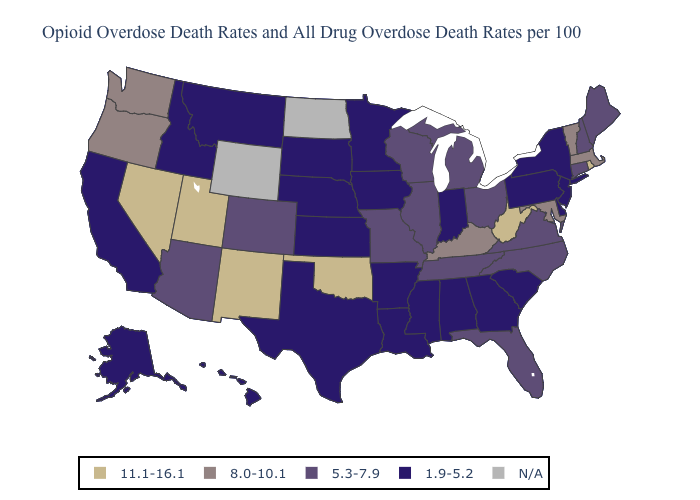Name the states that have a value in the range N/A?
Keep it brief. North Dakota, Wyoming. Which states hav the highest value in the MidWest?
Keep it brief. Illinois, Michigan, Missouri, Ohio, Wisconsin. Name the states that have a value in the range 5.3-7.9?
Answer briefly. Arizona, Colorado, Connecticut, Florida, Illinois, Maine, Michigan, Missouri, New Hampshire, North Carolina, Ohio, Tennessee, Virginia, Wisconsin. What is the lowest value in the South?
Concise answer only. 1.9-5.2. Which states have the lowest value in the West?
Write a very short answer. Alaska, California, Hawaii, Idaho, Montana. Name the states that have a value in the range 11.1-16.1?
Short answer required. Nevada, New Mexico, Oklahoma, Rhode Island, Utah, West Virginia. Name the states that have a value in the range 11.1-16.1?
Quick response, please. Nevada, New Mexico, Oklahoma, Rhode Island, Utah, West Virginia. Does the map have missing data?
Give a very brief answer. Yes. Which states have the lowest value in the USA?
Give a very brief answer. Alabama, Alaska, Arkansas, California, Delaware, Georgia, Hawaii, Idaho, Indiana, Iowa, Kansas, Louisiana, Minnesota, Mississippi, Montana, Nebraska, New Jersey, New York, Pennsylvania, South Carolina, South Dakota, Texas. Which states hav the highest value in the South?
Quick response, please. Oklahoma, West Virginia. Among the states that border Florida , which have the highest value?
Keep it brief. Alabama, Georgia. Which states hav the highest value in the South?
Concise answer only. Oklahoma, West Virginia. What is the value of New Jersey?
Keep it brief. 1.9-5.2. How many symbols are there in the legend?
Short answer required. 5. 